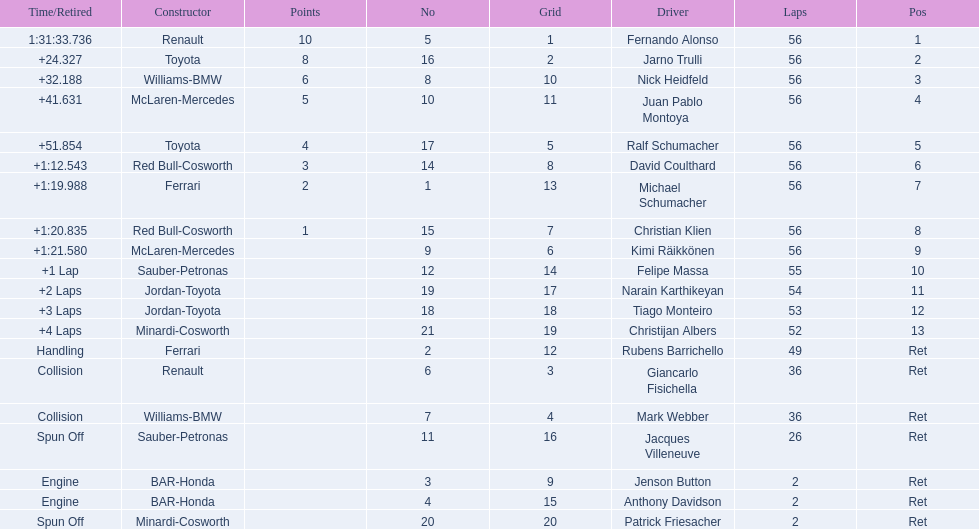How many racers faced an early end to the race as a result of engine troubles? 2. 